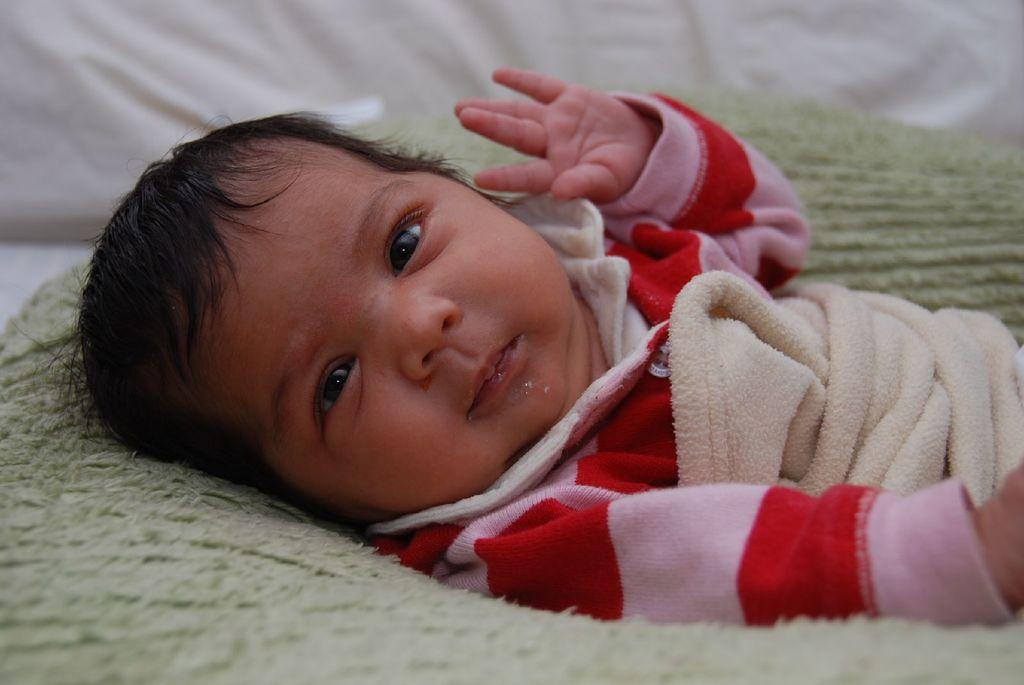What is the main subject of the picture? The main subject of the picture is a small baby. What is the baby wearing? The baby is wearing a pink and red color dress. Where is the baby located in the image? The baby is lying on the bed. What is the baby's facial expression or action in the image? The baby is looking at the camera. What can be seen in the background of the image? There is a white pillow in the background. Can you see a knot tied in the baby's dress in the image? There is no knot visible in the baby's dress in the image. What type of spark can be seen coming from the baby's eyes in the image? There is no spark visible coming from the baby's eyes in the image. 